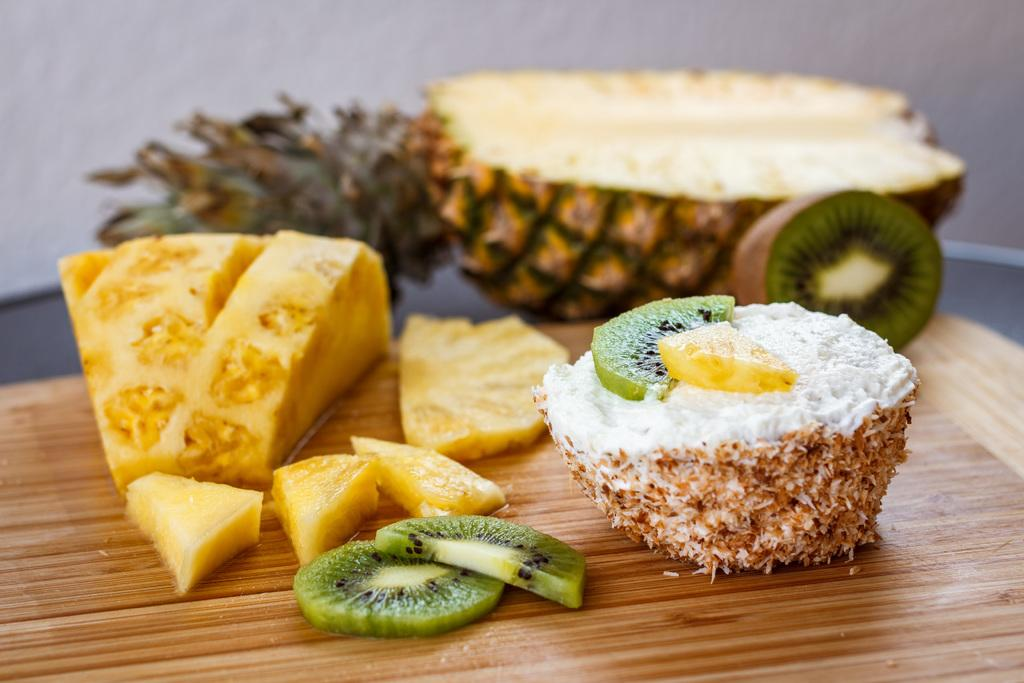What is present in the image? There are food items in the image. Where are the food items located? The food items are on an object. Can you describe the background of the image? The background of the image is blurred. What type of thunder can be heard in the image? There is no thunder present in the image, as it is a still image and does not contain any sound. 